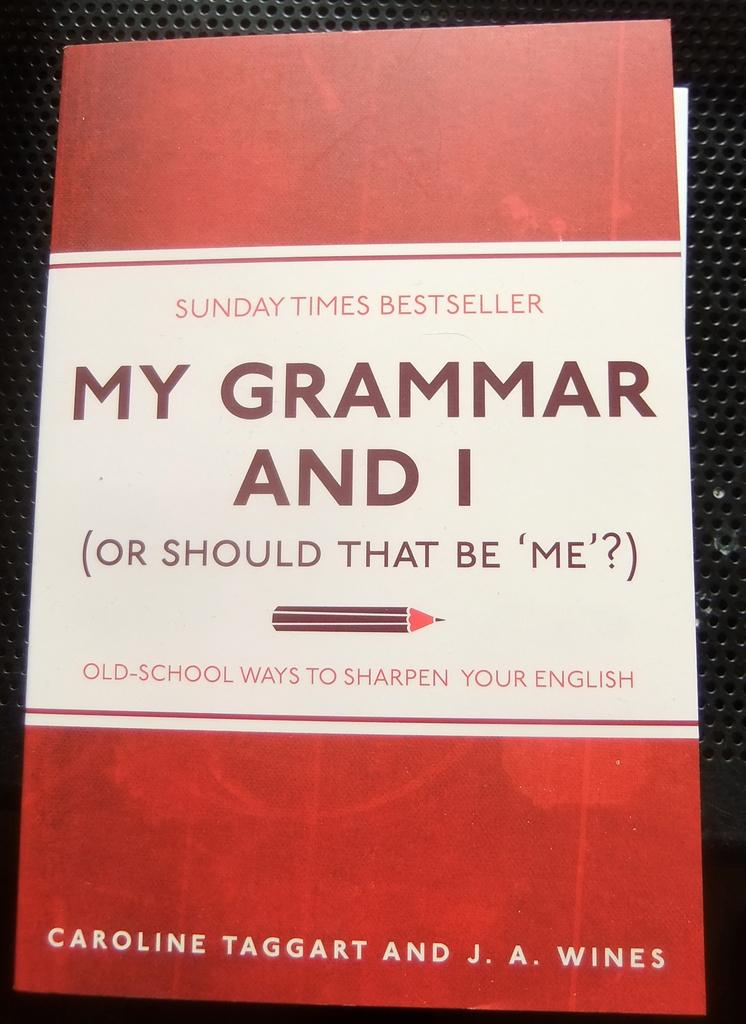<image>
Relay a brief, clear account of the picture shown. a book that is titled 'my grammar and i ( or should that be 'me'?)' 